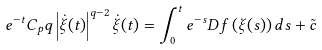<formula> <loc_0><loc_0><loc_500><loc_500>e ^ { - t } C _ { p } q \left | \dot { \xi } ( t ) \right | ^ { q - 2 } \dot { \xi } ( t ) = \int _ { 0 } ^ { t } e ^ { - s } D f \left ( \xi ( s ) \right ) d s + \tilde { c }</formula> 